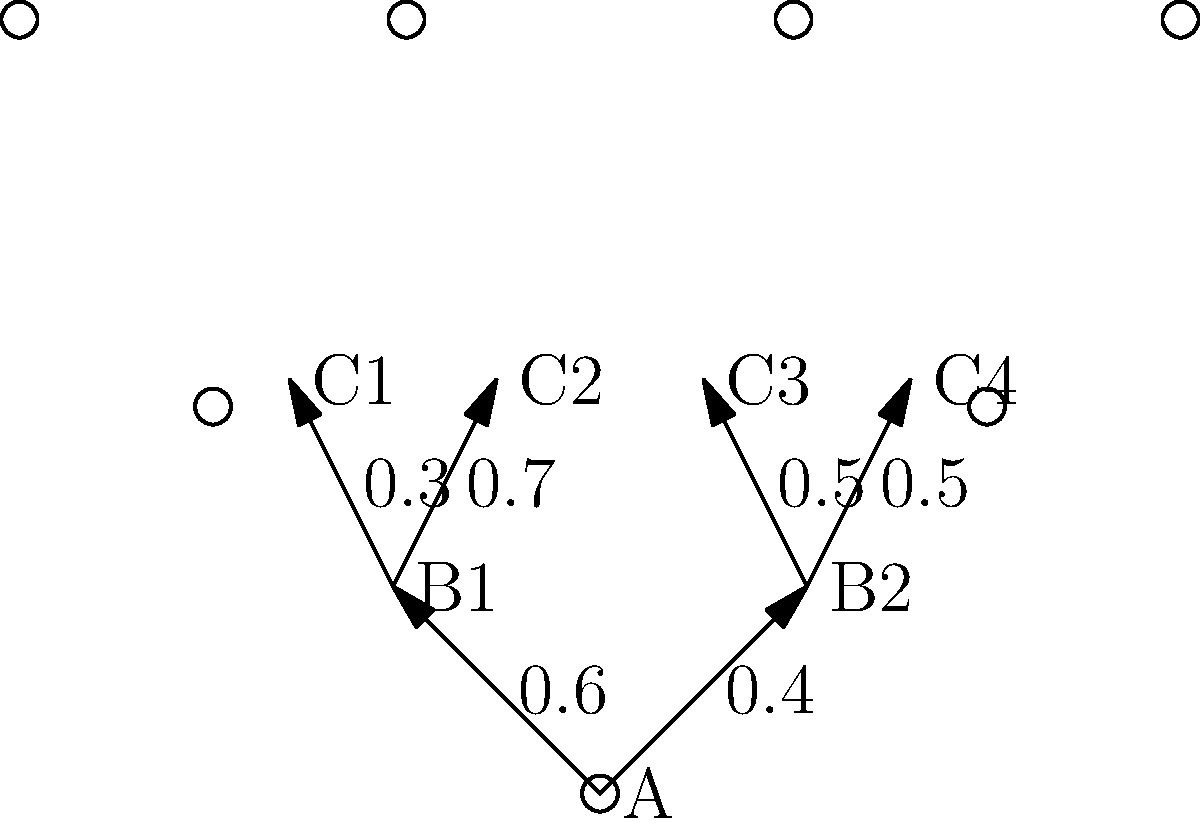In a multi-stage game, a player progresses through stages A, B, and C as shown in the game tree. The probabilities of each path are indicated on the edges. Calculate the probability of the player ending up at node C2. To calculate the probability of ending up at node C2, we need to follow these steps:

1) Identify the path to C2:
   The path to C2 is A → B1 → C2

2) Calculate the probability of this path:
   - Probability of A → B1 = 0.6
   - Probability of B1 → C2 = 0.7

3) Multiply these probabilities:
   $P(\text{C2}) = P(\text{A} \to \text{B1}) \times P(\text{B1} \to \text{C2})$
   $P(\text{C2}) = 0.6 \times 0.7$

4) Perform the calculation:
   $P(\text{C2}) = 0.42$

Therefore, the probability of the player ending up at node C2 is 0.42 or 42%.
Answer: 0.42 